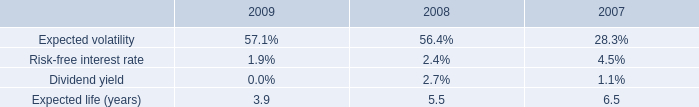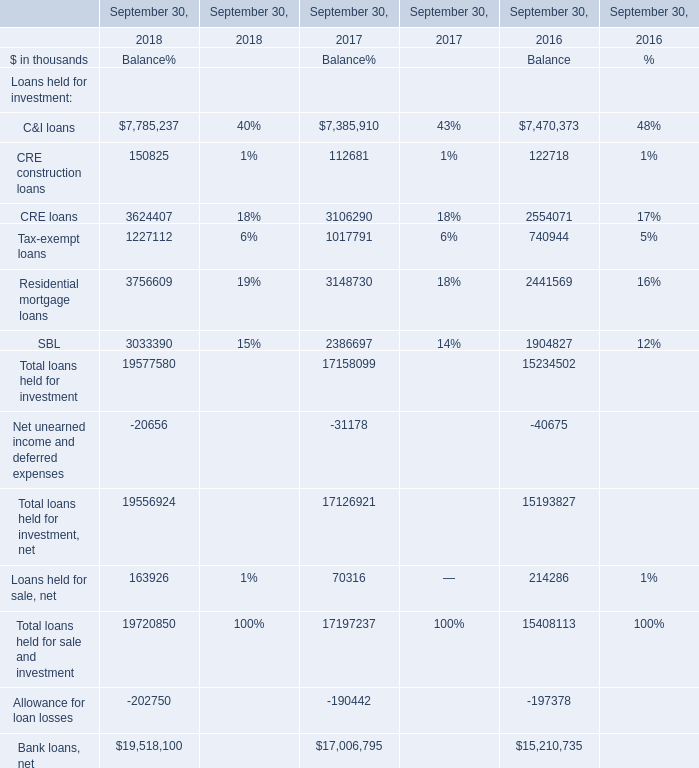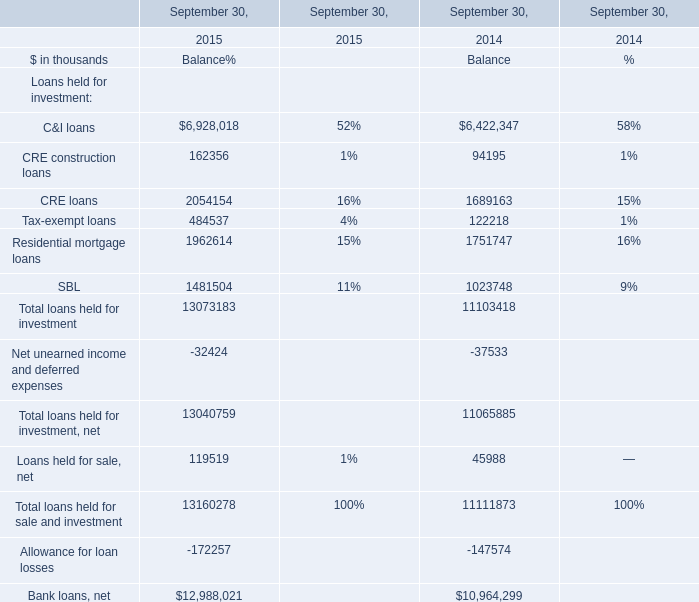What's the current increasing rate of Balance for CRE loans on September 30? 
Computations: ((2054154 - 1689163) / 1689163)
Answer: 0.21608. what was the average company 2019s expenses , primarily relating to the employer match from 2007 to 2009 for all defined contribution plans in millions 
Computations: ((((8 + 95) + 116) + 3) / 2)
Answer: 111.0. 